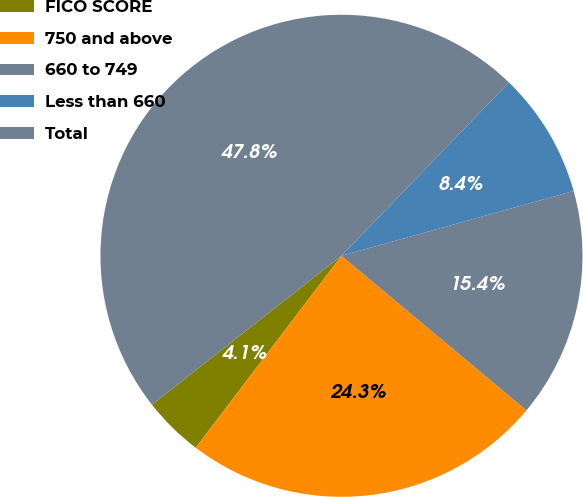Convert chart. <chart><loc_0><loc_0><loc_500><loc_500><pie_chart><fcel>FICO SCORE<fcel>750 and above<fcel>660 to 749<fcel>Less than 660<fcel>Total<nl><fcel>4.06%<fcel>24.26%<fcel>15.41%<fcel>8.44%<fcel>47.82%<nl></chart> 